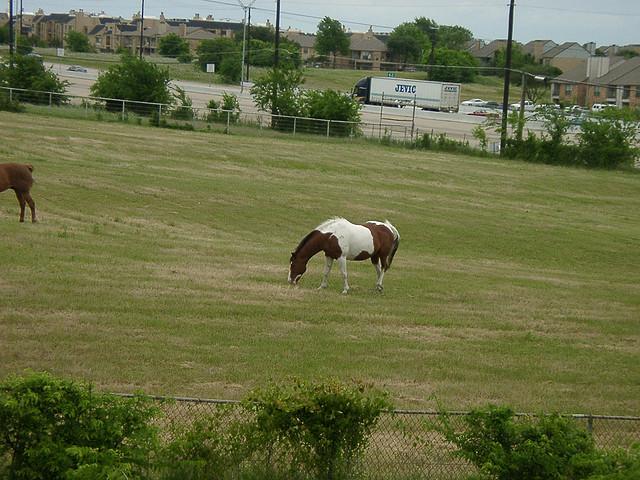What is present?
Write a very short answer. Horse. What type of fur is that?
Write a very short answer. Horse. How many short horses do you see?
Concise answer only. 1. What animal are these?
Be succinct. Horses. What type of animal is on the field?
Be succinct. Horse. What brand is on the truck?
Answer briefly. Jetix. How many animals are there?
Quick response, please. 2. How many houses are in this photo?
Give a very brief answer. 2. How many horses are in the photo?
Concise answer only. 2. What color are all the houses?
Write a very short answer. Tan. What type of animals are in the picture?
Be succinct. Horses. Which animals are these?
Keep it brief. Horses. 